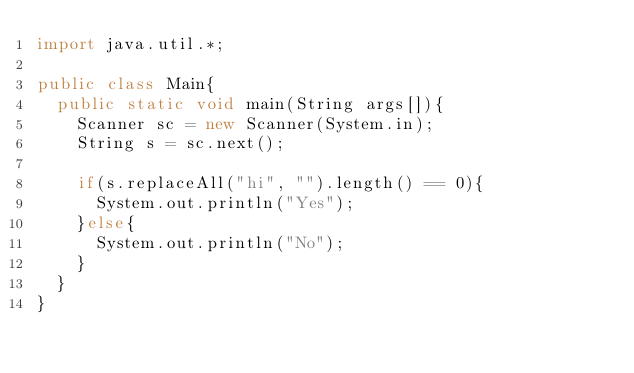Convert code to text. <code><loc_0><loc_0><loc_500><loc_500><_Java_>import java.util.*;

public class Main{
  public static void main(String args[]){
    Scanner sc = new Scanner(System.in);
    String s = sc.next();
    
    if(s.replaceAll("hi", "").length() == 0){
      System.out.println("Yes");
    }else{
      System.out.println("No");
    }
  }
}</code> 